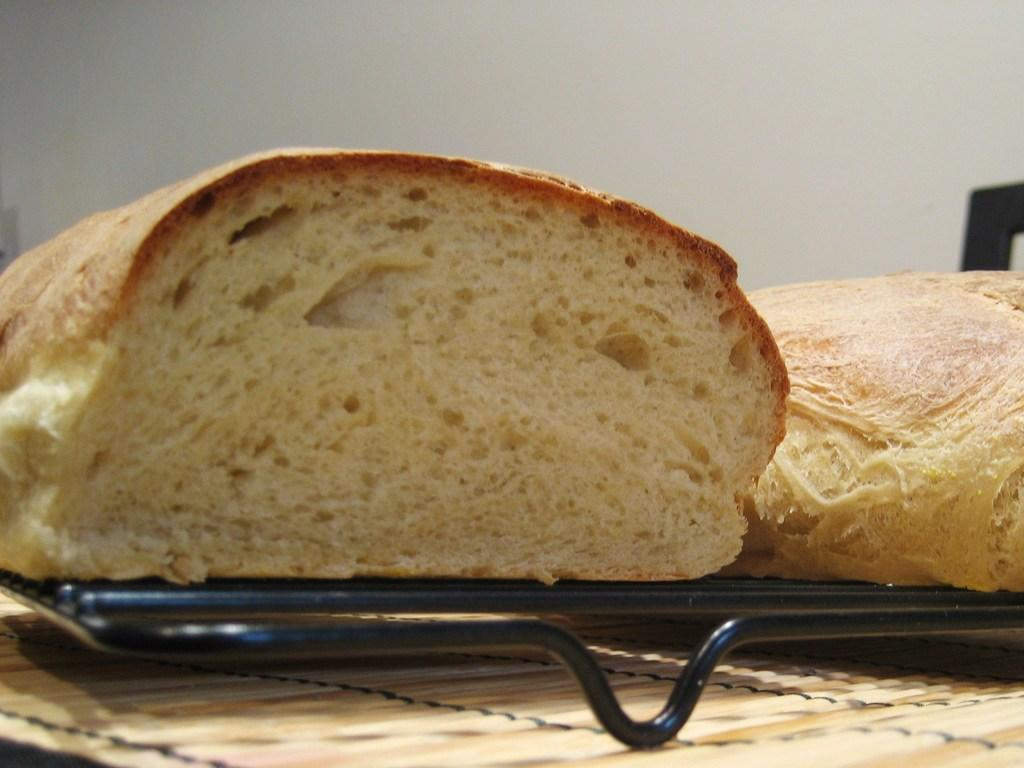What is the main subject of the image? There is a food item in the image. What is the food item placed on? The food item is on a black color object. What can be seen in the background of the image? There is a white color wall in the background of the image. Can you tell me how many lizards are crawling on the leather sofa in the image? There is no leather sofa or lizards present in the image. 